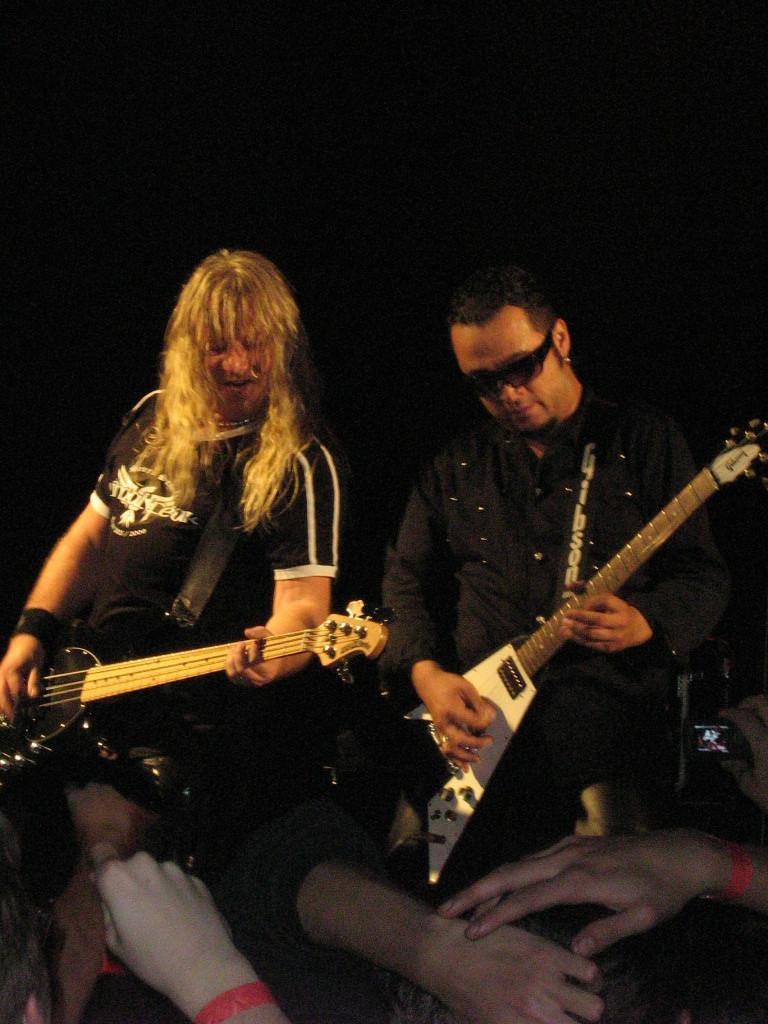What are the two persons in the center of the image doing? The two persons in the center of the image are holding guitars. What can be seen at the bottom of the image? There are people standing at the bottom of the image. What are some of the people at the bottom holding? Some of the people at the bottom are holding cameras. What type of cake is being served at the bottom of the image? There is no cake present in the image; the people at the bottom are holding cameras. 